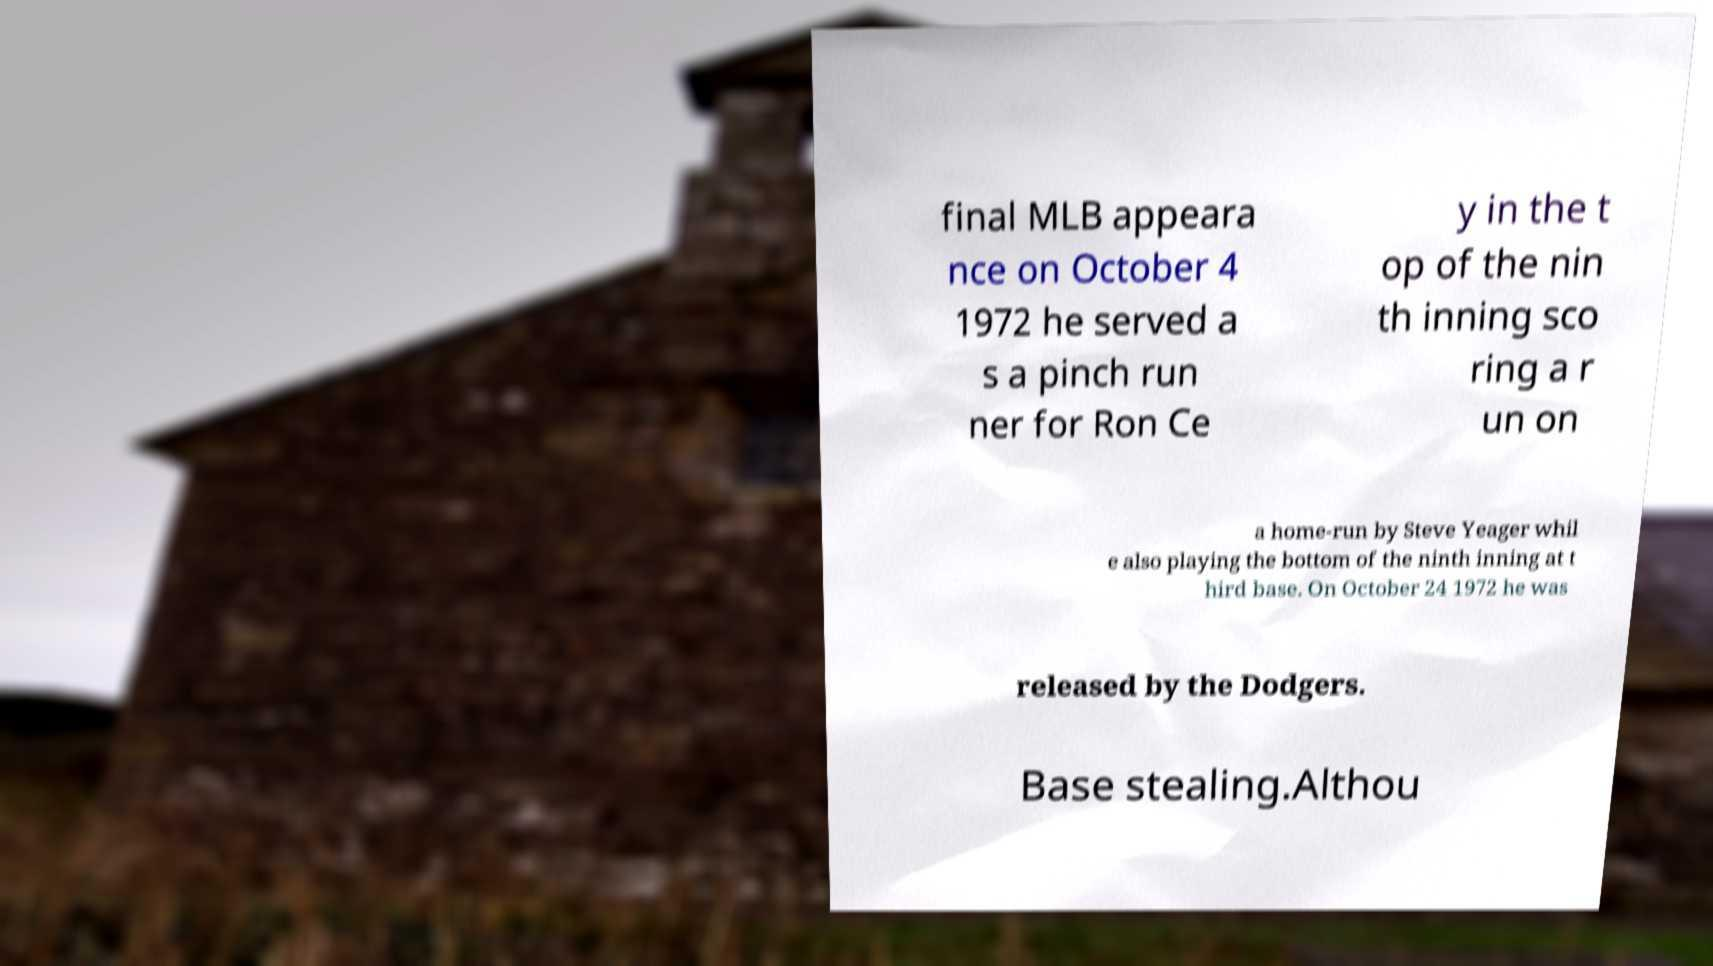Could you extract and type out the text from this image? final MLB appeara nce on October 4 1972 he served a s a pinch run ner for Ron Ce y in the t op of the nin th inning sco ring a r un on a home-run by Steve Yeager whil e also playing the bottom of the ninth inning at t hird base. On October 24 1972 he was released by the Dodgers. Base stealing.Althou 